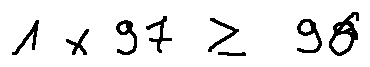Convert formula to latex. <formula><loc_0><loc_0><loc_500><loc_500>1 \times 9 7 \geq 9 6</formula> 